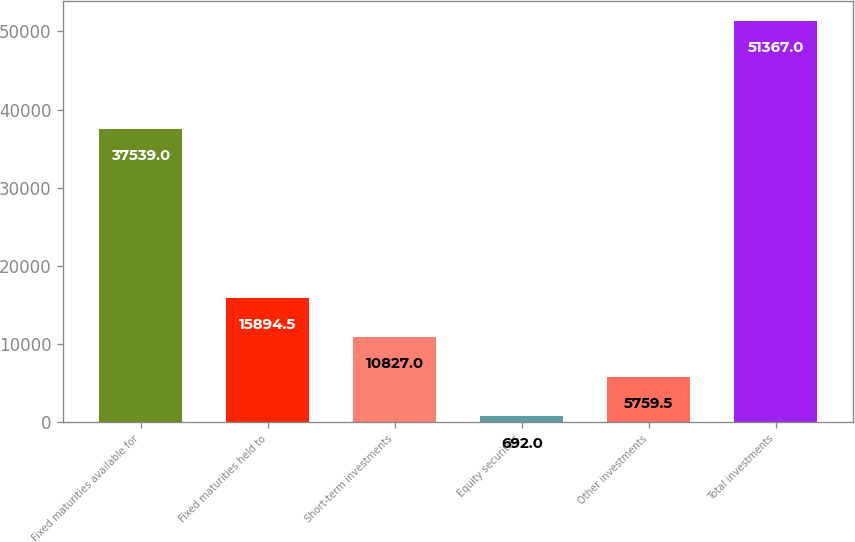Convert chart. <chart><loc_0><loc_0><loc_500><loc_500><bar_chart><fcel>Fixed maturities available for<fcel>Fixed maturities held to<fcel>Short-term investments<fcel>Equity securities<fcel>Other investments<fcel>Total investments<nl><fcel>37539<fcel>15894.5<fcel>10827<fcel>692<fcel>5759.5<fcel>51367<nl></chart> 